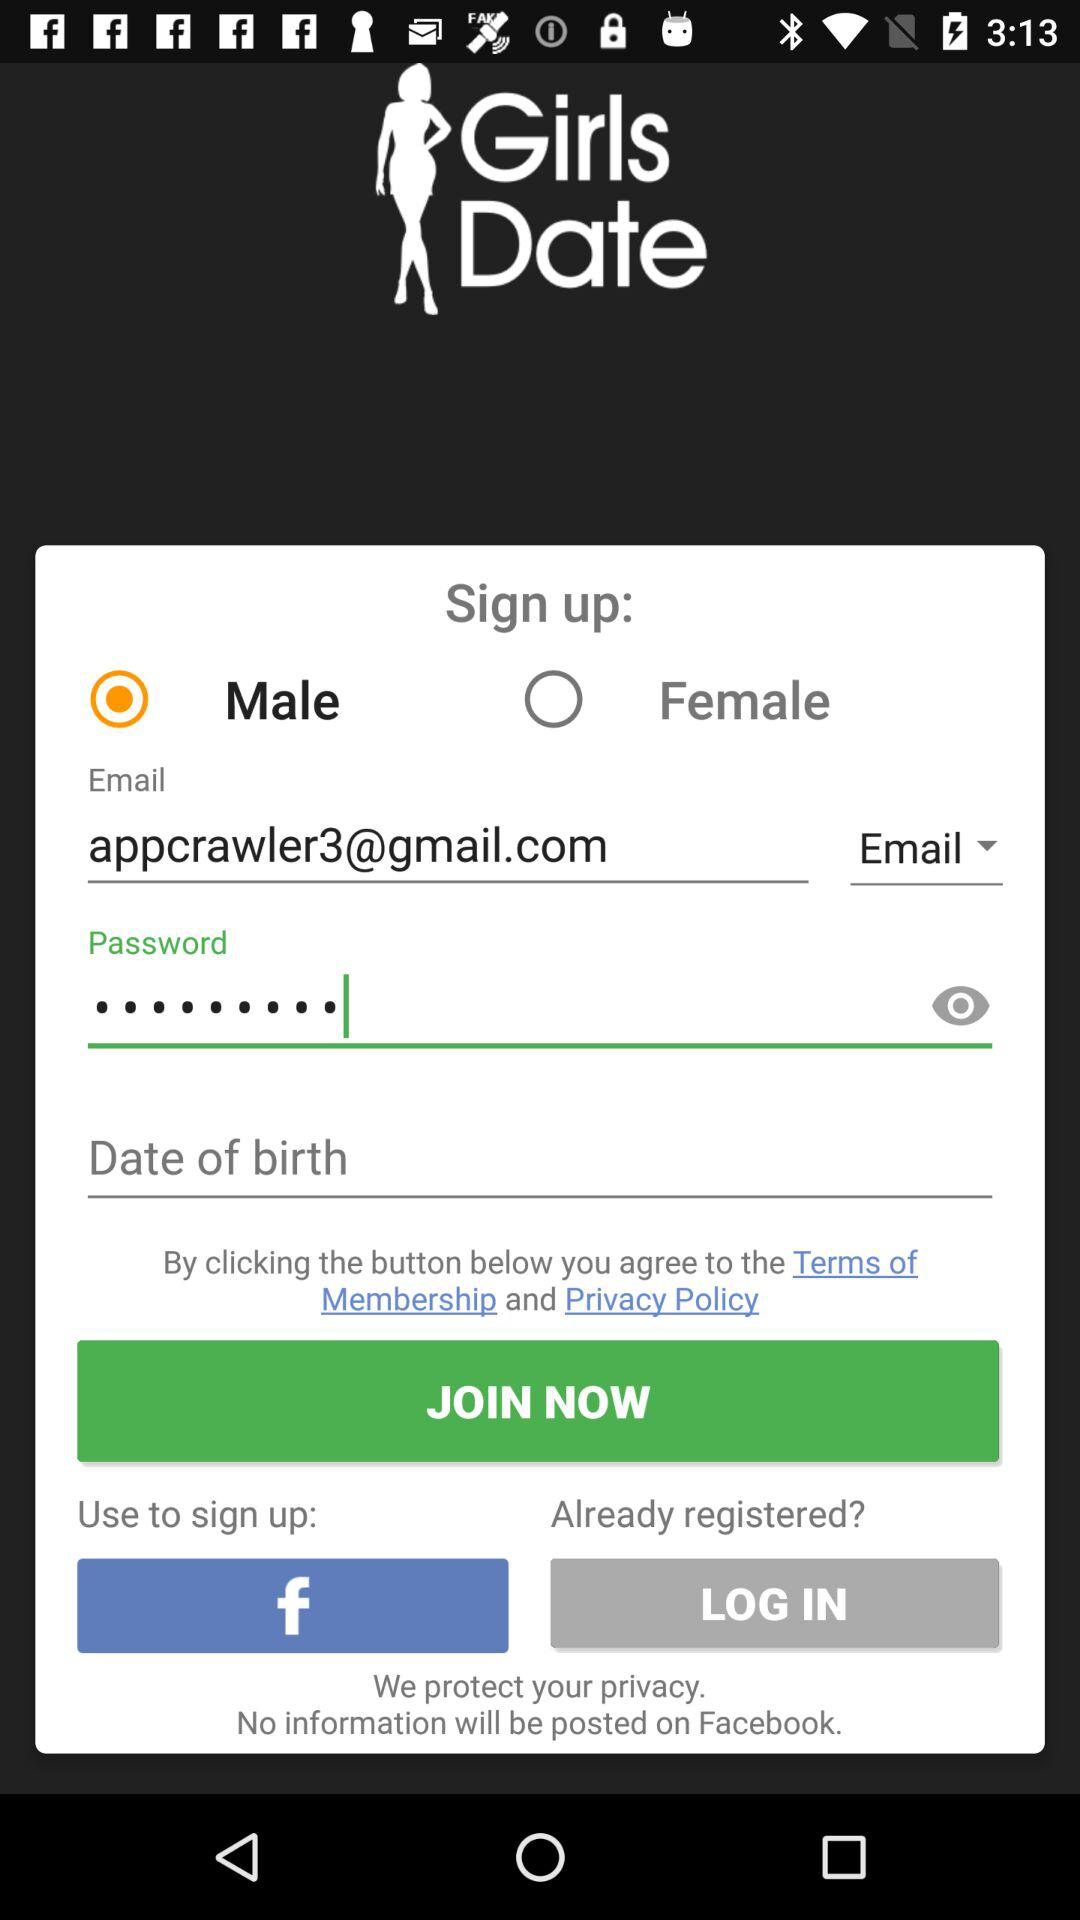What is the application name? The application name is "Girls Date". 